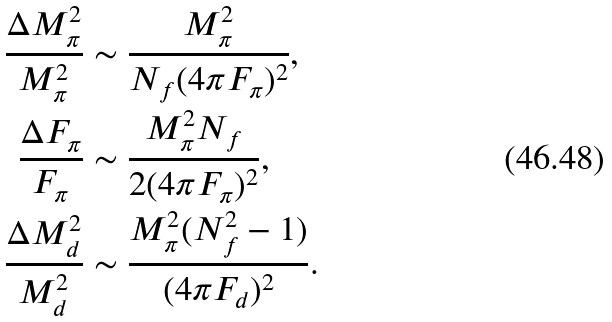<formula> <loc_0><loc_0><loc_500><loc_500>\frac { \Delta M ^ { 2 } _ { \pi } } { M ^ { 2 } _ { \pi } } & \sim \frac { M ^ { 2 } _ { \pi } } { N _ { f } ( 4 \pi F _ { \pi } ) ^ { 2 } } , \\ \frac { \Delta F _ { \pi } } { F _ { \pi } } & \sim \frac { M ^ { 2 } _ { \pi } N _ { f } } { 2 ( 4 \pi F _ { \pi } ) ^ { 2 } } , \\ \frac { \Delta M ^ { 2 } _ { d } } { M ^ { 2 } _ { d } } & \sim \frac { M ^ { 2 } _ { \pi } ( N ^ { 2 } _ { f } - 1 ) } { ( 4 \pi F _ { d } ) ^ { 2 } } .</formula> 